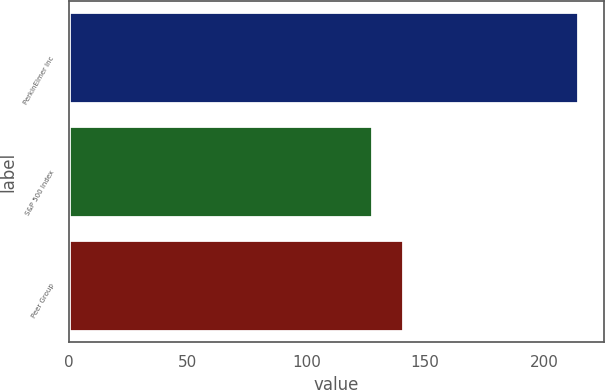Convert chart to OTSL. <chart><loc_0><loc_0><loc_500><loc_500><bar_chart><fcel>PerkinElmer Inc<fcel>S&P 500 Index<fcel>Peer Group<nl><fcel>214.31<fcel>127.47<fcel>140.61<nl></chart> 